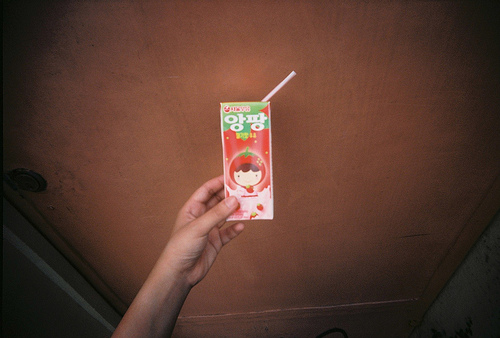<image>
Can you confirm if the juice is on the girl? Yes. Looking at the image, I can see the juice is positioned on top of the girl, with the girl providing support. 